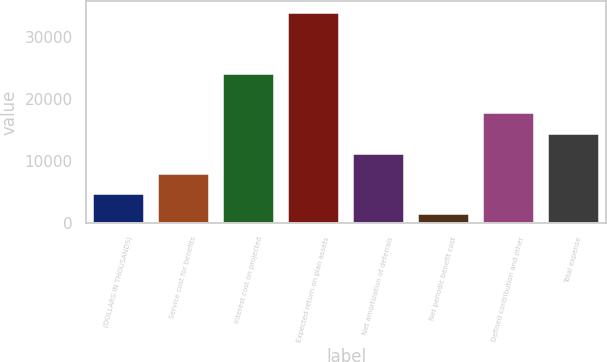<chart> <loc_0><loc_0><loc_500><loc_500><bar_chart><fcel>(DOLLARS IN THOUSANDS)<fcel>Service cost for benefits<fcel>Interest cost on projected<fcel>Expected return on plan assets<fcel>Net amortization of deferrals<fcel>Net periodic benefit cost<fcel>Defined contribution and other<fcel>Total expense<nl><fcel>4815.4<fcel>8056.8<fcel>24096<fcel>33988<fcel>11298.2<fcel>1574<fcel>17781<fcel>14539.6<nl></chart> 